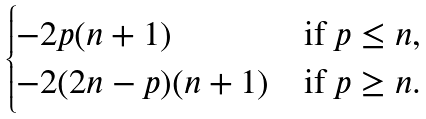Convert formula to latex. <formula><loc_0><loc_0><loc_500><loc_500>\begin{cases} - 2 p ( n + 1 ) & \text {if $p\leq n$} , \\ - 2 ( 2 n - p ) ( n + 1 ) & \text {if $p\geq n$} . \end{cases}</formula> 